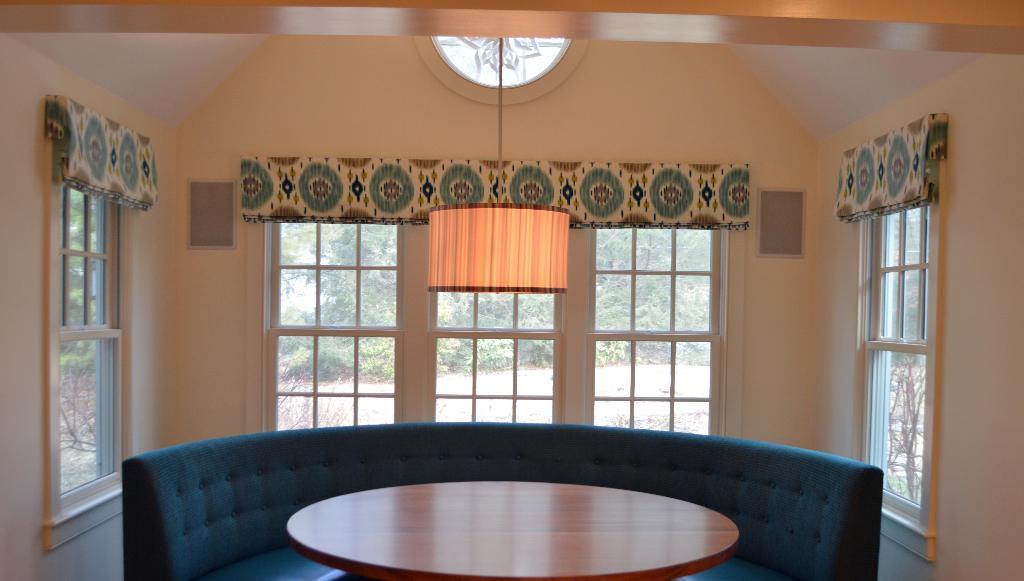Could you give a brief overview of what you see in this image? In the center of the image there is a light and windows. On the right side of the image there is a window. On the left side of the image we can see window. At the bottom there table and sofa. In the background there are trees. 